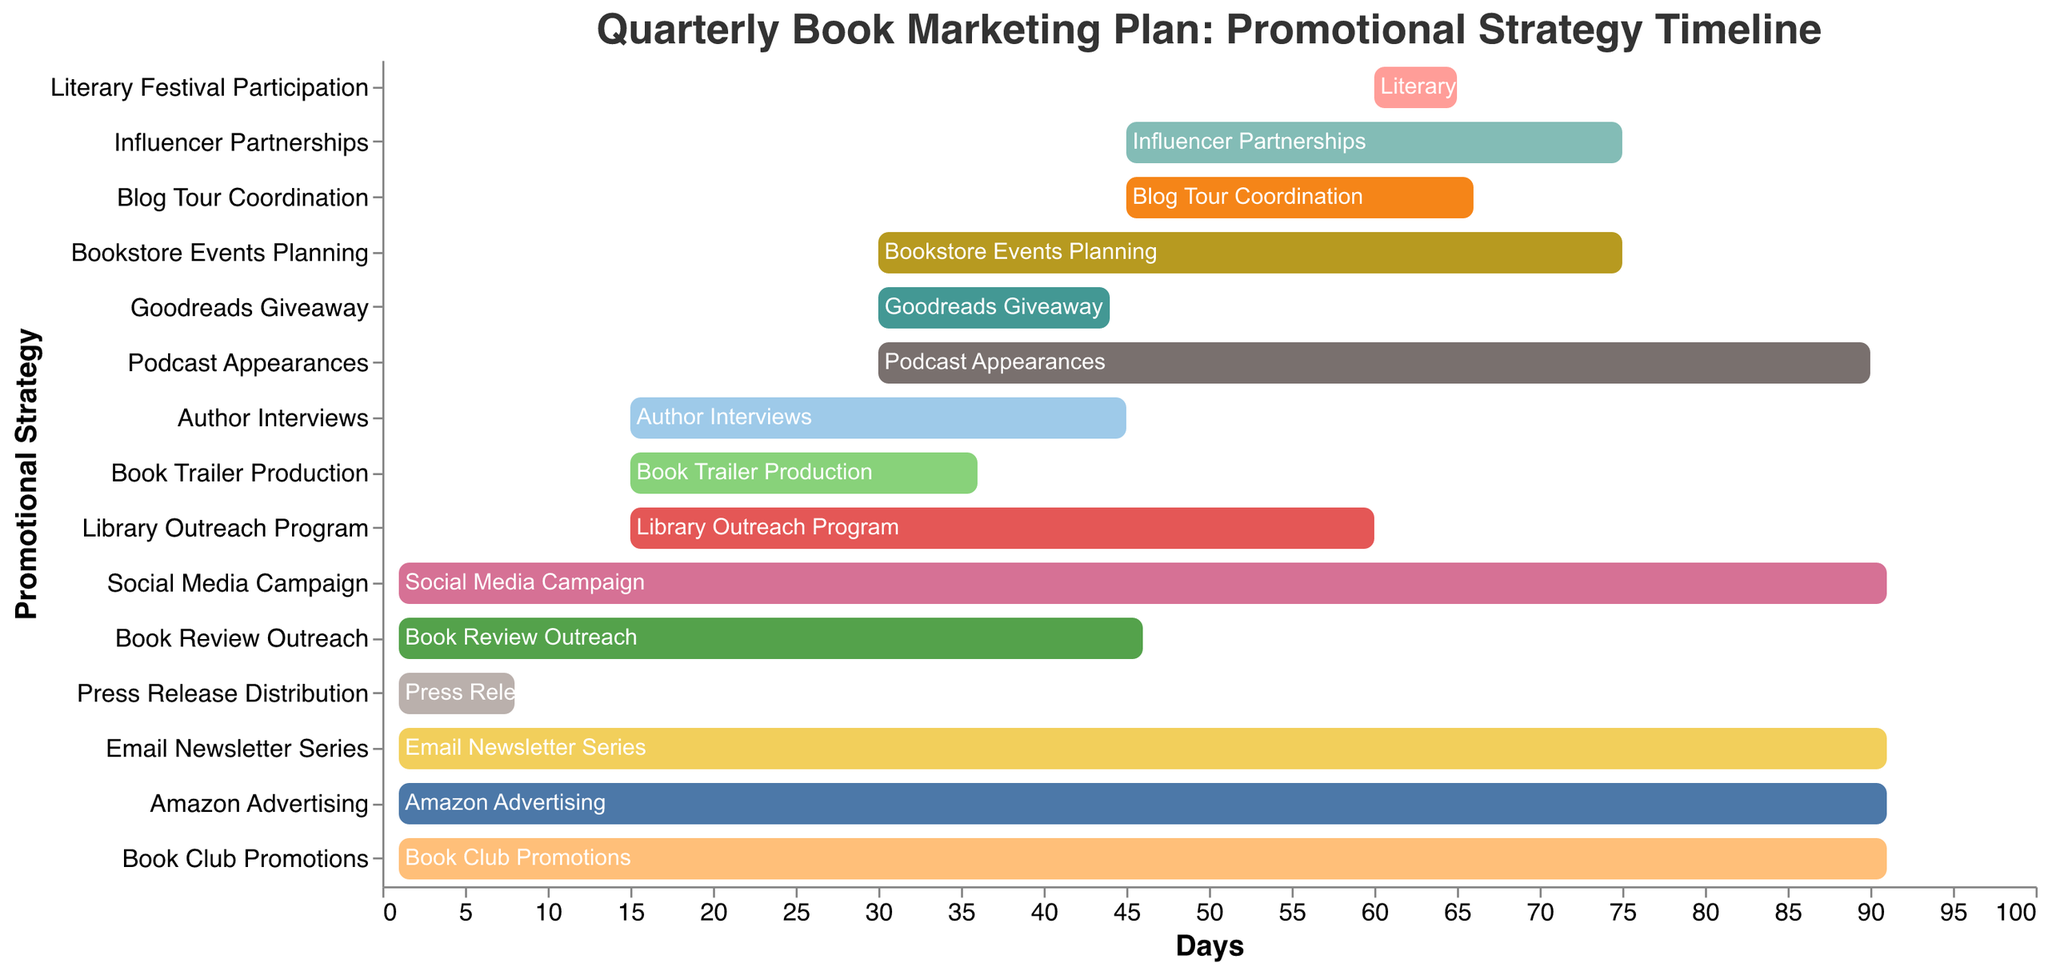What's the longest promotional strategy in the plan? By examining the Gantt chart, the longest promotional strategies are identified by the span of their bars. The "Social Media Campaign," "Email Newsletter Series," "Amazon Advertising," and "Book Club Promotions" each last for 90 days.
Answer: Social Media Campaign, Email Newsletter Series, Amazon Advertising, Book Club Promotions What's the shortest promotional strategy, and how many days does it last? The shortest bar in the figure indicates the shortest strategy, which is the "Literary Festival Participation," lasting 5 days.
Answer: Literary Festival Participation, 5 days Which promotional strategy starts the latest in the quarterly plan? To identify the latest starting strategy, look for the bar with the highest start value. "Literary Festival Participation" starts on day 60, which is the latest.
Answer: Literary Festival Participation How many strategies begin on the first day? By counting the bars that start at day 1 on the x-axis, we observe that there are 6 strategies: "Social Media Campaign," "Book Review Outreach," "Press Release Distribution," "Email Newsletter Series," "Amazon Advertising," and "Book Club Promotions."
Answer: 6 Which strategies overlap in their timeline with "Author Interviews"? "Author Interviews" starts on day 15 and lasts for 30 days (ends on day 45). The strategies overlapping with this time frame are identified by checking their bars' start and end days against this period. "Author Interviews," "Book Trailer Production," "Library Outreach Program," and any strategy starting on or before day 15 and ending on or after day 15 overlap.
Answer: Book Trailer Production, Library Outreach Program How long does the "Podcast Appearances" strategy last? Check the duration specified for "Podcast Appearances," which is denoted by the length of the bar. It lasts for 60 days.
Answer: 60 days Which strategies are already in progress by the time "Goodreads Giveaway" begins? "Goodreads Giveaway" starts on day 30. Any strategy starting before or on day 30 and not yet finished by day 30 is considered in progress. These include "Social Media Campaign," "Book Review Outreach," "Bookstore Events Planning," "Email Newsletter Series," "Amazon Advertising," and "Book Club Promotions."
Answer: Social Media Campaign, Book Review Outreach, Bookstore Events Planning, Email Newsletter Series, Amazon Advertising, Book Club Promotions Which two strategies share the same duration but do not overlap in their timelines? First, find the durations that are the same but have non-overlapping start and end days. "Influencer Partnerships" and "Library Outreach Program" both last 45 days but begin on different days, avoiding an overlap.
Answer: Influencer Partnerships, Library Outreach Program How many days does the "Press Release Distribution" extend? According to the chart, "Press Release Distribution" spans 7 days.
Answer: 7 days 